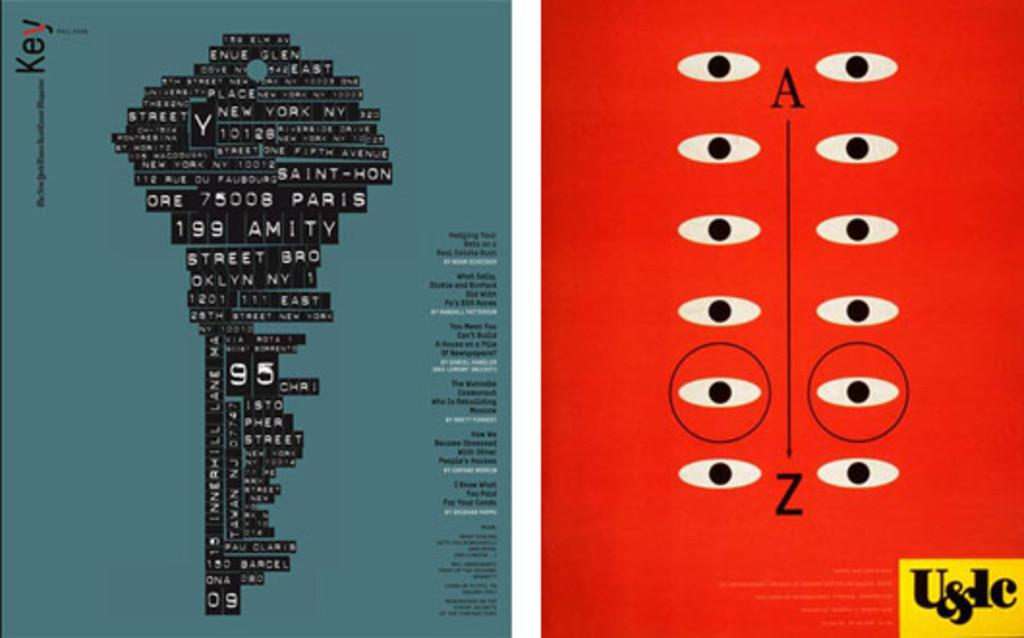<image>
Relay a brief, clear account of the picture shown. A graphic of a key is composed of words including Amity Street. 